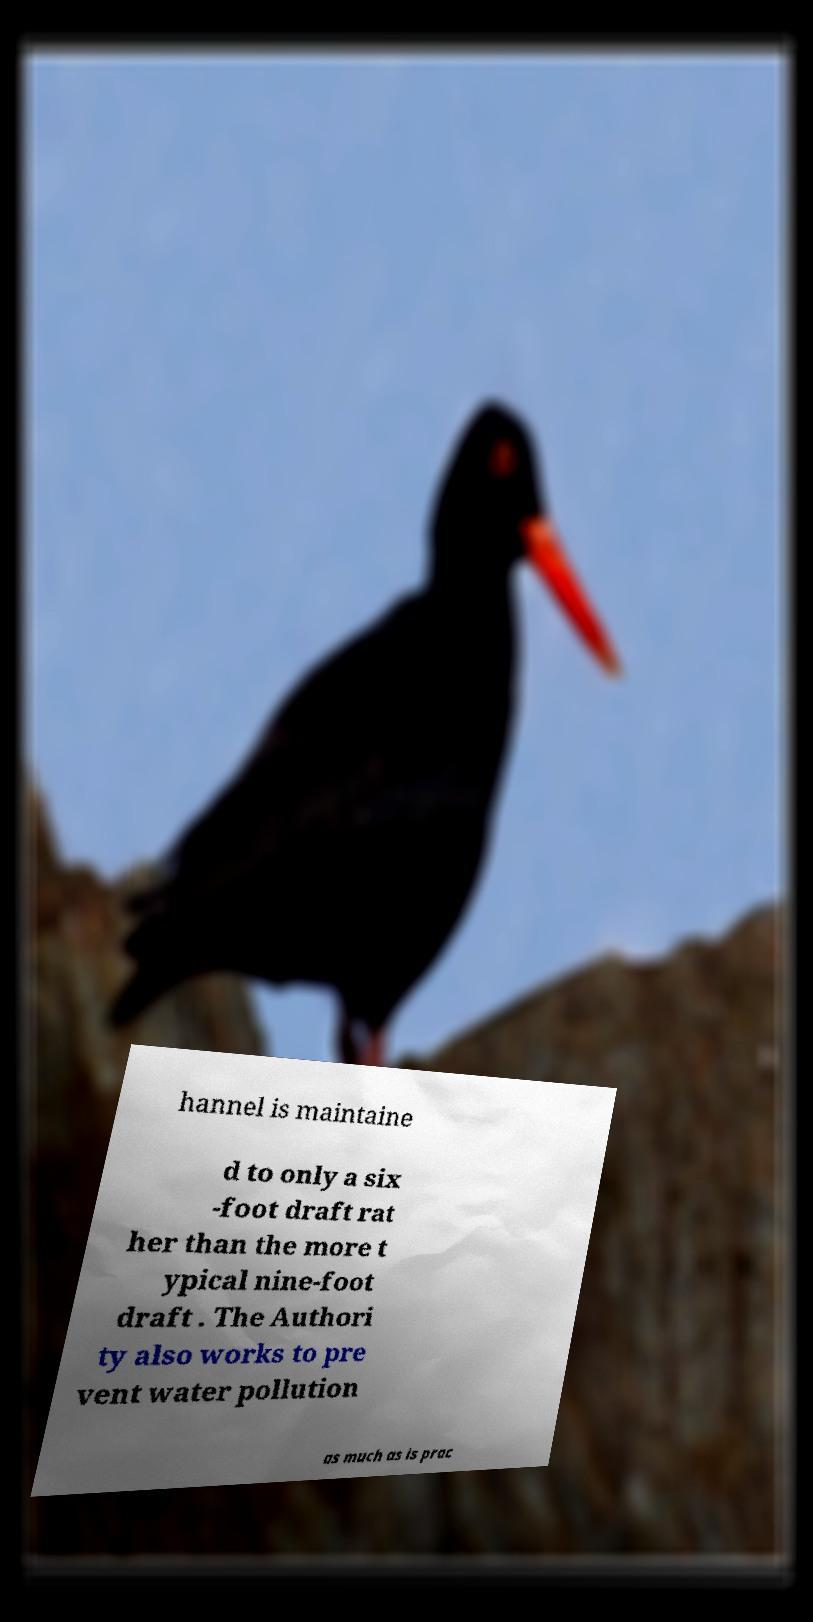Could you assist in decoding the text presented in this image and type it out clearly? hannel is maintaine d to only a six -foot draft rat her than the more t ypical nine-foot draft . The Authori ty also works to pre vent water pollution as much as is prac 